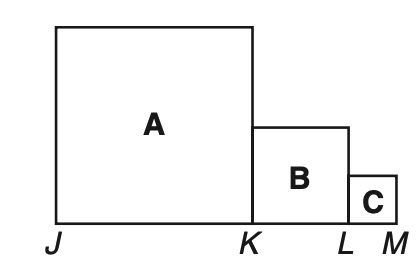In the figure consisting of squares A, B, and C, J K = 2K L and K L = 2L M. If the perimeter of the figure is 66 units, what is the area? To determine the area of the entire figure, we must first understand the relationship between the lengths of the segments. Given J K = 2K L and K L = 2L M, we can deduce that the side lengths of squares A, B, and C are in a ratio where square A's side is twice as long as square B's, and square B's side is twice as long as square C's. To find the area, we would typically define the single smallest side length, say 'x', and express the other lengths in terms of 'x'. We would then calculate the perimeter in terms of 'x' and solve for 'x' using the given perimeter of 66 units. Once 'x' is determined, we can calculate the areas of the squares and sum them up for the total area. However, without proper calculation, any provided option might not be correct. It is important to verify the calculations before concluding the right choice. 